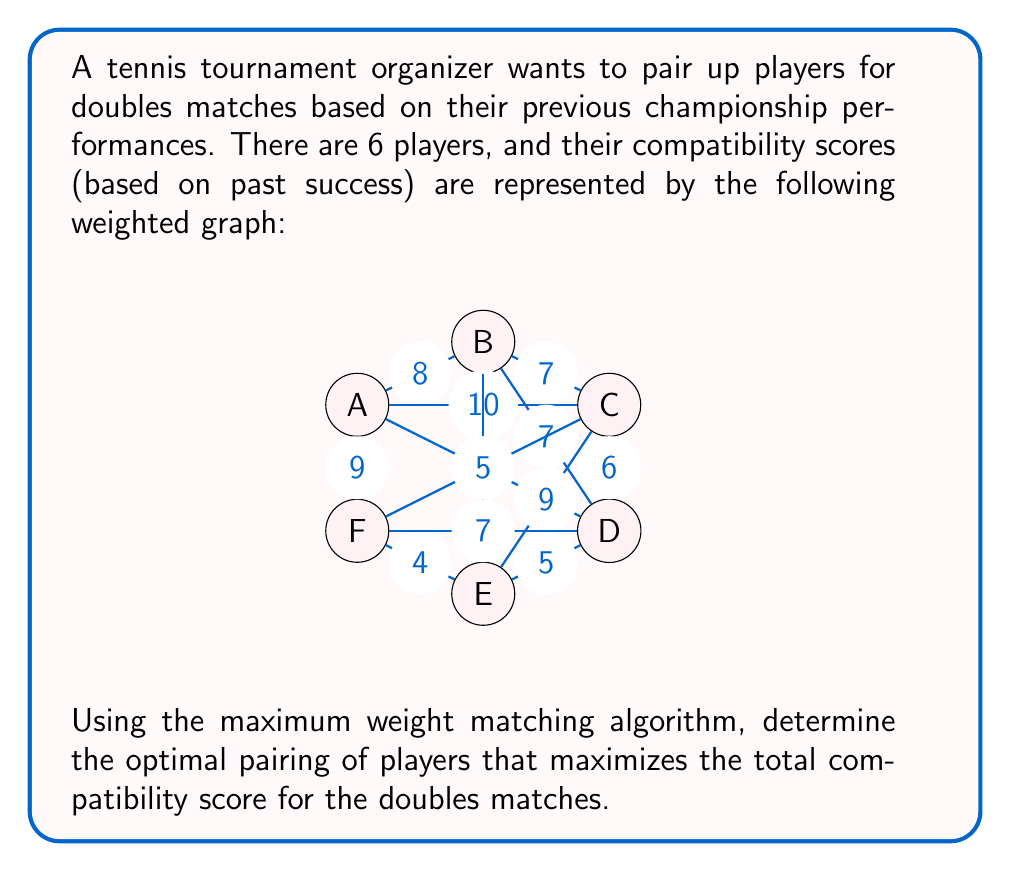Can you solve this math problem? To solve this problem, we need to find the maximum weight matching in the given graph. Here's a step-by-step explanation:

1) First, we need to identify all possible pairings and their weights:
   AB: 8, AC: 10, AD: 6, AE: not directly connected, AF: 9
   BC: 7, BD: 7, BE: 8, BF: not directly connected
   CD: 6, CE: 9, CF: 5
   DE: 5, DF: 7
   EF: 4

2) We'll use the greedy algorithm to find the maximum weight matching:

   a) Start with the highest weight edge: AC (10)
   b) The next highest weight edge that doesn't share a vertex with AC is BE (8)
   c) The remaining vertices (D and F) form the last pair with weight 7

3) The resulting matching is:
   A-C (10), B-E (8), D-F (7)

4) The total weight of this matching is 10 + 8 + 7 = 25

5) To verify this is indeed the maximum weight matching, we can check other possible combinations:
   - A-B (8), C-E (9), D-F (7): Total = 24
   - A-F (9), B-C (7), D-E (5): Total = 21
   - A-D (6), B-E (8), C-F (5): Total = 19

   None of these alternatives yield a higher total than our solution.

Therefore, the optimal pairing that maximizes the total compatibility score is A-C, B-E, and D-F, with a total score of 25.
Answer: The optimal pairing is: A-C, B-E, D-F, with a total compatibility score of 25. 